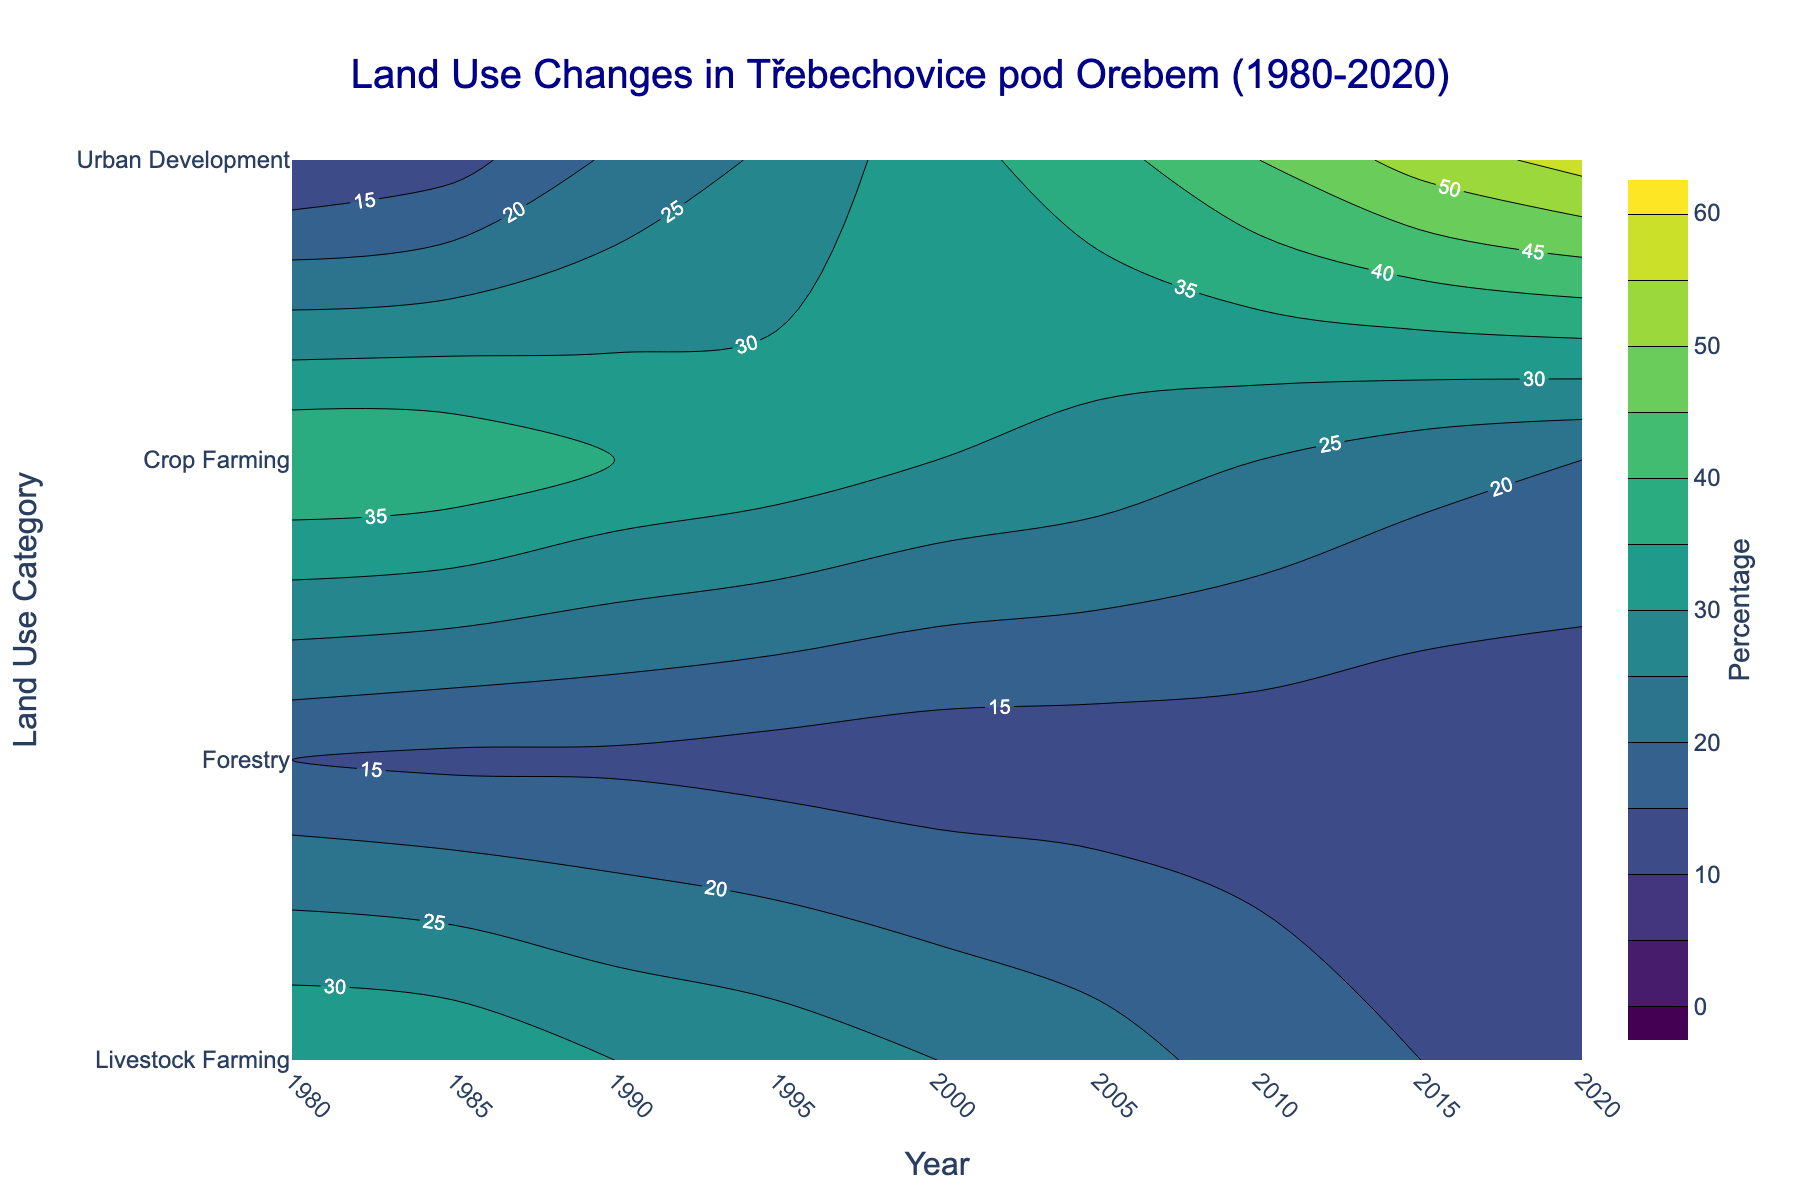what is the title of the plot? The title is displayed at the top of the plot and usually summarizes the main theme or subject being depicted. Here, the title is centered at the top and reads: 'Land Use Changes in Třebechovice pod Orebem (1980-2020).'
Answer: Land Use Changes in Třebechovice pod Orebem (1980-2020) How did Urban Development change from 1980 to 2020? Observe the contours for 'Urban Development' at the years 1980 and 2020. The color and labels show the percentage values. In 1980, Urban Development was at 10%, and it increased to 57% by 2020.
Answer: Increased from 10% to 57% Which category shows the most significant decrease over the years? Compare the contour colors and labels for all categories between the earliest year (1980) and the latest year (2020). 'Livestock Farming' starts at 35% in 1980 and drops to 12% in 2020, showing the most significant decrease.
Answer: Livestock Farming What is the general trend for Forestry from 1980 to 2020? Examine the 'Forestry' category along the y-axis and trace the contour lines from 1980 to 2020. The contours remain relatively unchanged, showing a consistent percentage around 12-15%.
Answer: Remains relatively constant Which year showed the highest percentage for Urban Development? Identify the darkest color or the highest contour label associated with 'Urban Development.' The highest value is found in 2020.
Answer: 2020 By how much did Crop Farming decrease from 1990 to 2015? Find the percentage values for 'Crop Farming' at 1990 (35%) and 2015 (22%), then subtract the later value from the earlier one (35% - 22%).
Answer: 13% What were the percentages of Livestock Farming and Urban Development in 1995? Trace the contour lines for 'Livestock Farming' and 'Urban Development' at the year 1995. Livestock Farming is at 28%, and Urban Development is at 26%.
Answer: 28% and 26% In which decade did the most significant decline in Crop Farming occur? Observe the contour lines for 'Crop Farming' and identify any steep drops. The most significant decline appears between 1990 and 2000, where it dropped from 35% to 30%.
Answer: 1990-2000 